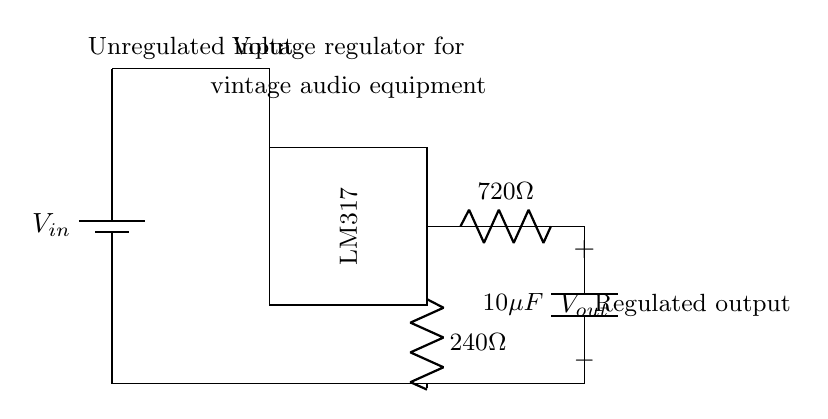What is the input voltage of the circuit? The input voltage is represented as \( V_{in} \) and is connected to the top of the circuit, indicating that it is the source voltage supplied to the circuit.
Answer: Vin What type of voltage regulator is used? The circuit diagram specifies that the voltage regulator is an LM317, clearly labeled inside the rectangular shape representing the voltage regulator IC.
Answer: LM317 What is the value of the output capacitor? The output capacitor is labeled as \( 10\mu F \), which can be seen in the circuit diagram at the output side, indicating its capacitance value.
Answer: 10 microfarads How many resistors are present in the circuit? There are two resistors in the circuit, indicated by the symbols with the labels \( 240\Omega \) and \( 720\Omega \), both drawn in the circuit.
Answer: 2 What is the purpose of the LM317 in this circuit? The LM317 serves as a voltage regulator, which adjusts and stabilizes the output voltage supplied to vintage audio equipment, maintaining the quality of audio signals.
Answer: Voltage regulation What is the output voltage of this regulated circuit? To determine the output voltage \( V_{out} \), analyze the resistors and the LM317 configuration. The output voltage is set by these resistors but the exact value is not provided in the diagram and requires calculation based on the resistor values.
Answer: Variable (requires calculations) What is the function of the 720-ohm resistor? The 720-ohm resistor is part of the voltage divider configuration used to set the output voltage level of the LM317. It works alongside the 240-ohm resistor to dictate the voltage output based on the regulator's characteristics.
Answer: Voltage setting 